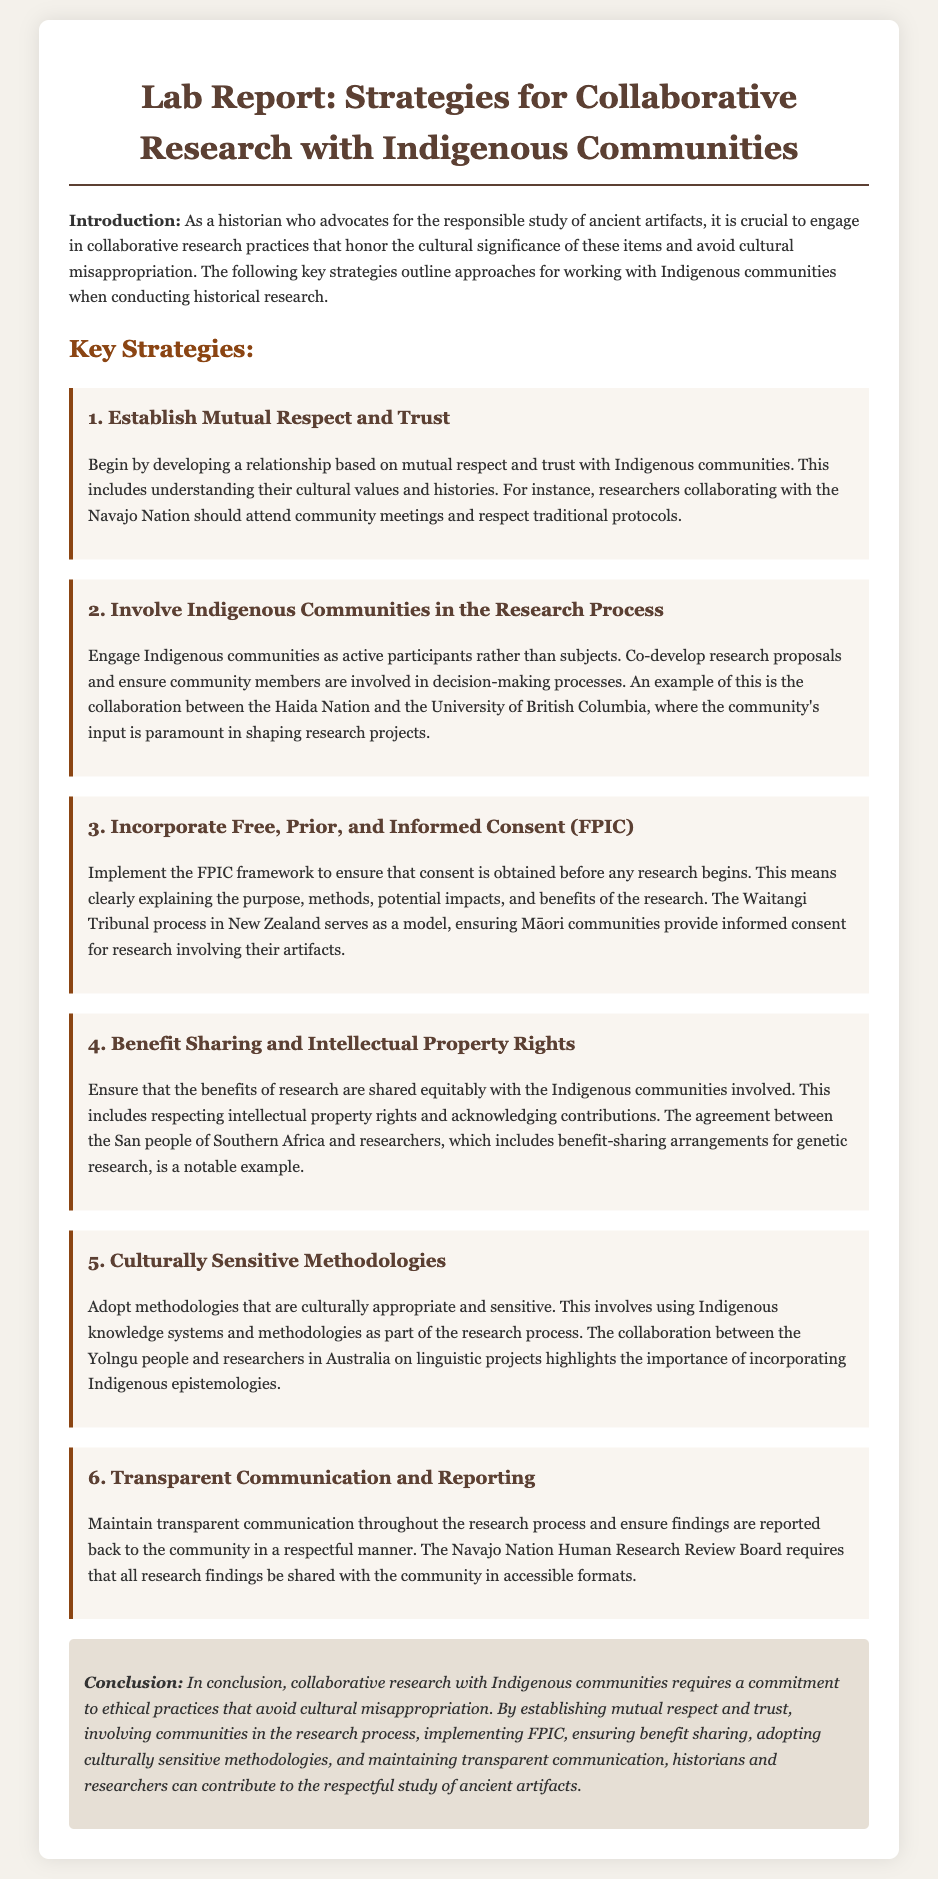What is the title of the lab report? The title of the lab report is provided in an `<h1>` element at the top of the document.
Answer: Strategies for Collaborative Research with Indigenous Communities What are the Navajo Nation's expectations for researchers? The document states that researchers should attend community meetings and respect traditional protocols when collaborating with the Navajo Nation.
Answer: Attend community meetings and respect traditional protocols Which framework must be implemented to ensure informed consent? The framework referred to in the document for obtaining consent before commencing research is mentioned explicitly.
Answer: Free, Prior, and Informed Consent (FPIC) What is highlighted as a notable example of benefit sharing? The document mentions an agreement that serves as a notable example for benefit sharing in research, specifically between Indigenous people and researchers.
Answer: The agreement between the San people of Southern Africa and researchers Which methodology is emphasized for being culturally appropriate? The document discusses the importance of incorporating traditional Indigenous practices into research methodologies.
Answer: Culturally Sensitive Methodologies What is the main conclusion of the lab report? The conclusion summarizes the ethical practices necessary for collaborative research with Indigenous communities to avoid cultural misappropriation.
Answer: Collaborative research requires a commitment to ethical practices that avoid cultural misappropriation 